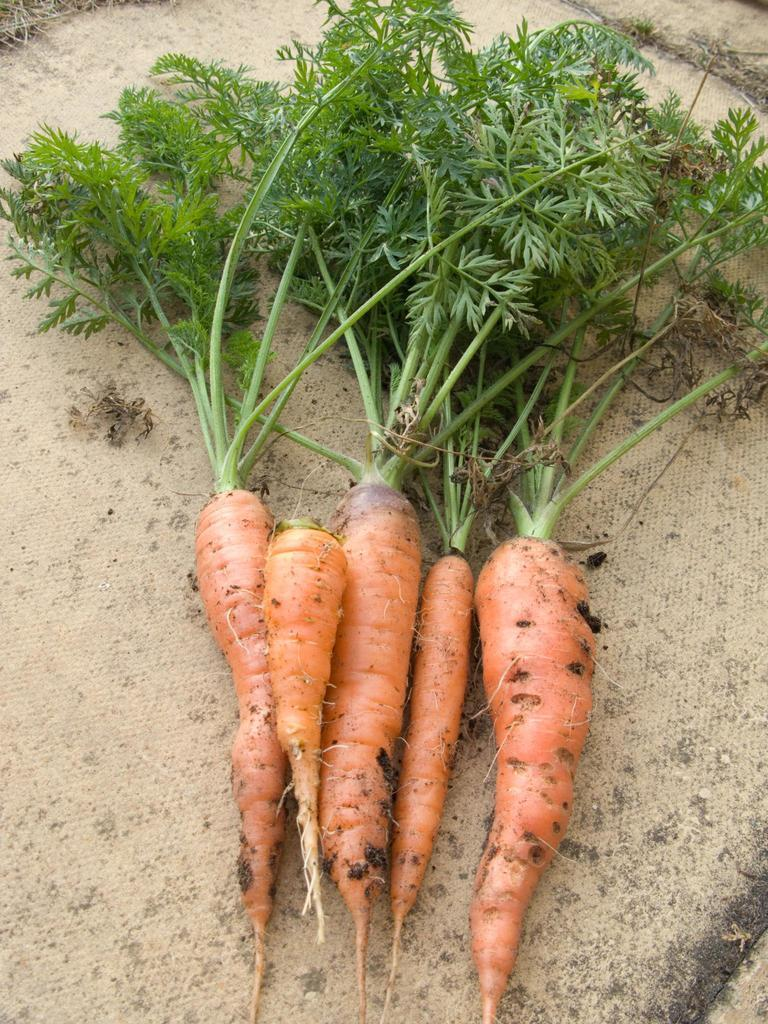What type of vegetable is present in the image? There are carrots with leaves in the image. What is visible at the bottom of the image? There is ground visible at the bottom of the image. What type of ghost can be seen interacting with the carrots in the image? There is no ghost present in the image; it features only carrots with leaves and ground. What is the income of the person who grew the carrots in the image? There is no information about the income of the person who grew the carrots in the image. 